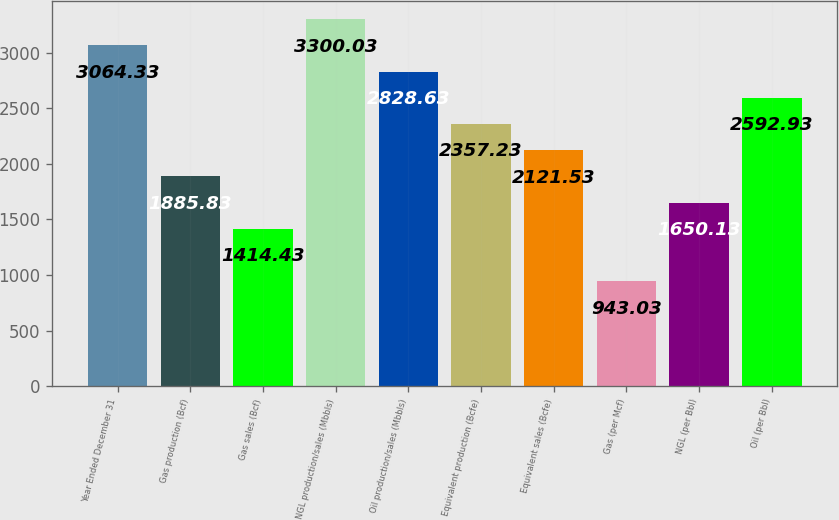Convert chart. <chart><loc_0><loc_0><loc_500><loc_500><bar_chart><fcel>Year Ended December 31<fcel>Gas production (Bcf)<fcel>Gas sales (Bcf)<fcel>NGL production/sales (Mbbls)<fcel>Oil production/sales (Mbbls)<fcel>Equivalent production (Bcfe)<fcel>Equivalent sales (Bcfe)<fcel>Gas (per Mcf)<fcel>NGL (per Bbl)<fcel>Oil (per Bbl)<nl><fcel>3064.33<fcel>1885.83<fcel>1414.43<fcel>3300.03<fcel>2828.63<fcel>2357.23<fcel>2121.53<fcel>943.03<fcel>1650.13<fcel>2592.93<nl></chart> 